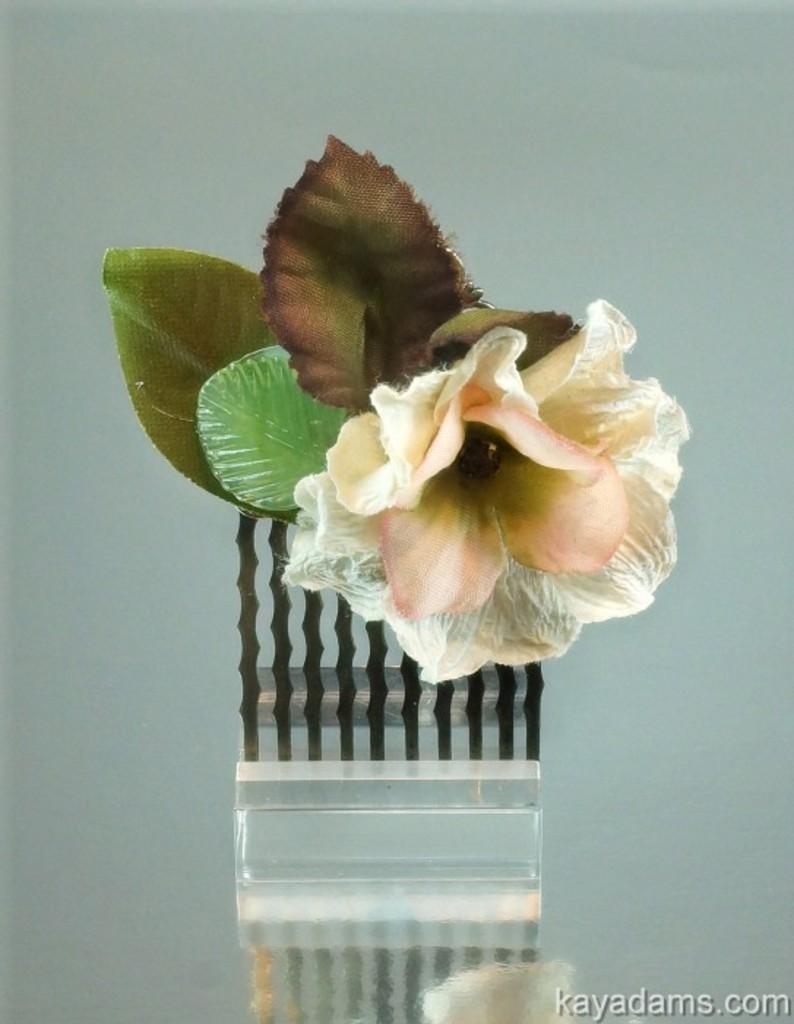What type of plant can be seen in the image? There is a flower with leaves in the image. Where are the flower and leaves located? The flower and leaves are inside an object. Where was the image obtained from? The image was taken from a website. Are the flowers and leaves real or artificial? A: The flowers and leaves are artificial. What type of juice can be seen in the image? There is no juice present in the image; it features a flower with leaves inside an object. 